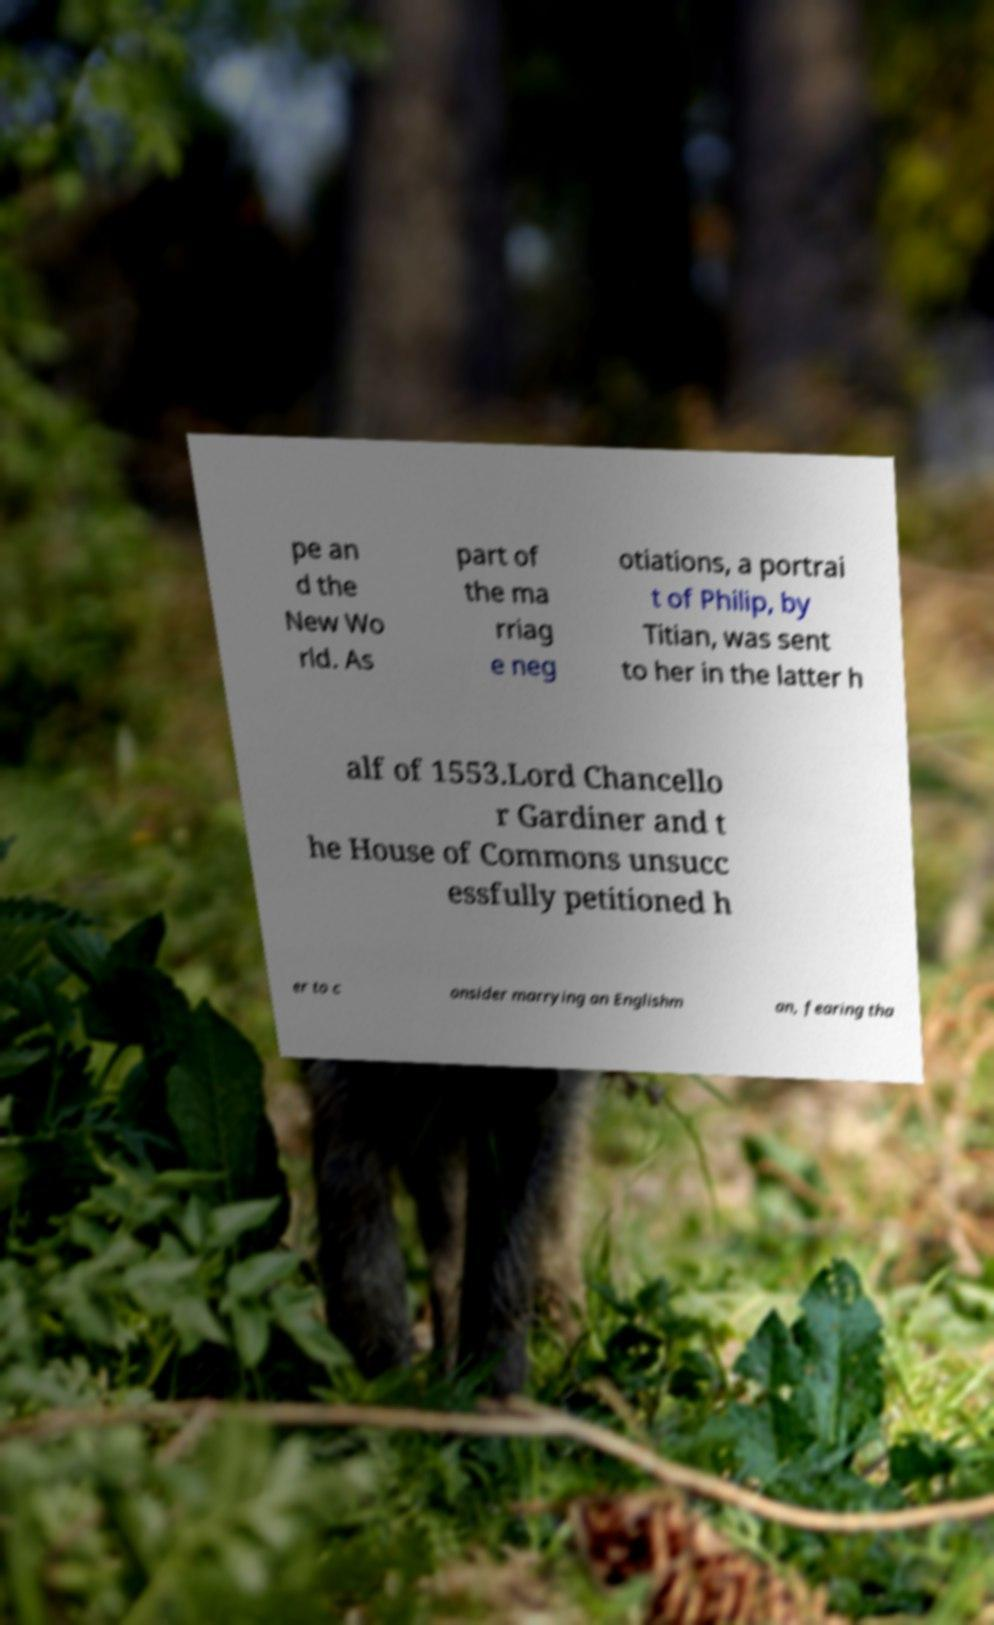What messages or text are displayed in this image? I need them in a readable, typed format. pe an d the New Wo rld. As part of the ma rriag e neg otiations, a portrai t of Philip, by Titian, was sent to her in the latter h alf of 1553.Lord Chancello r Gardiner and t he House of Commons unsucc essfully petitioned h er to c onsider marrying an Englishm an, fearing tha 